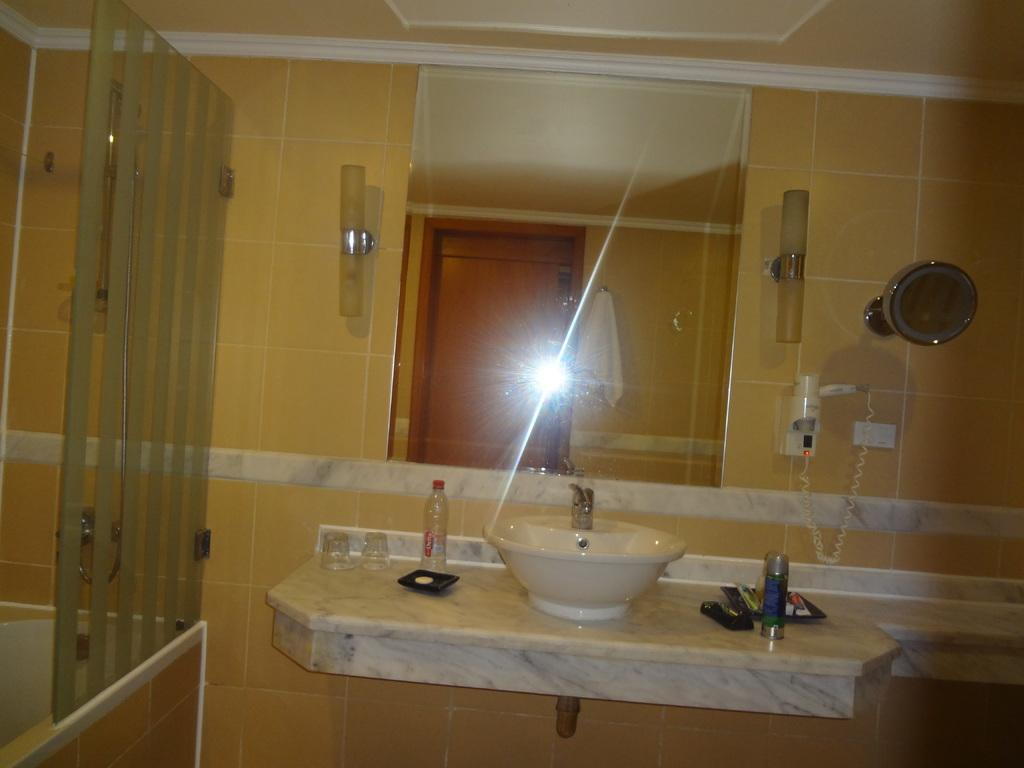What type of fixture is present in the image? There is a wash basin in the image. What can be used for drinking water in the image? There are water glasses in the image. What is available for cleaning hands in the image? There is a hand wash in the image. What can be used for personal grooming in the image? There is a mirror in the image. What type of coal can be seen in the image? There is no coal present in the image. How does the light in the image affect the visibility of the objects? The provided facts do not mention any light source in the image, so we cannot determine its effect on the visibility of the objects. 